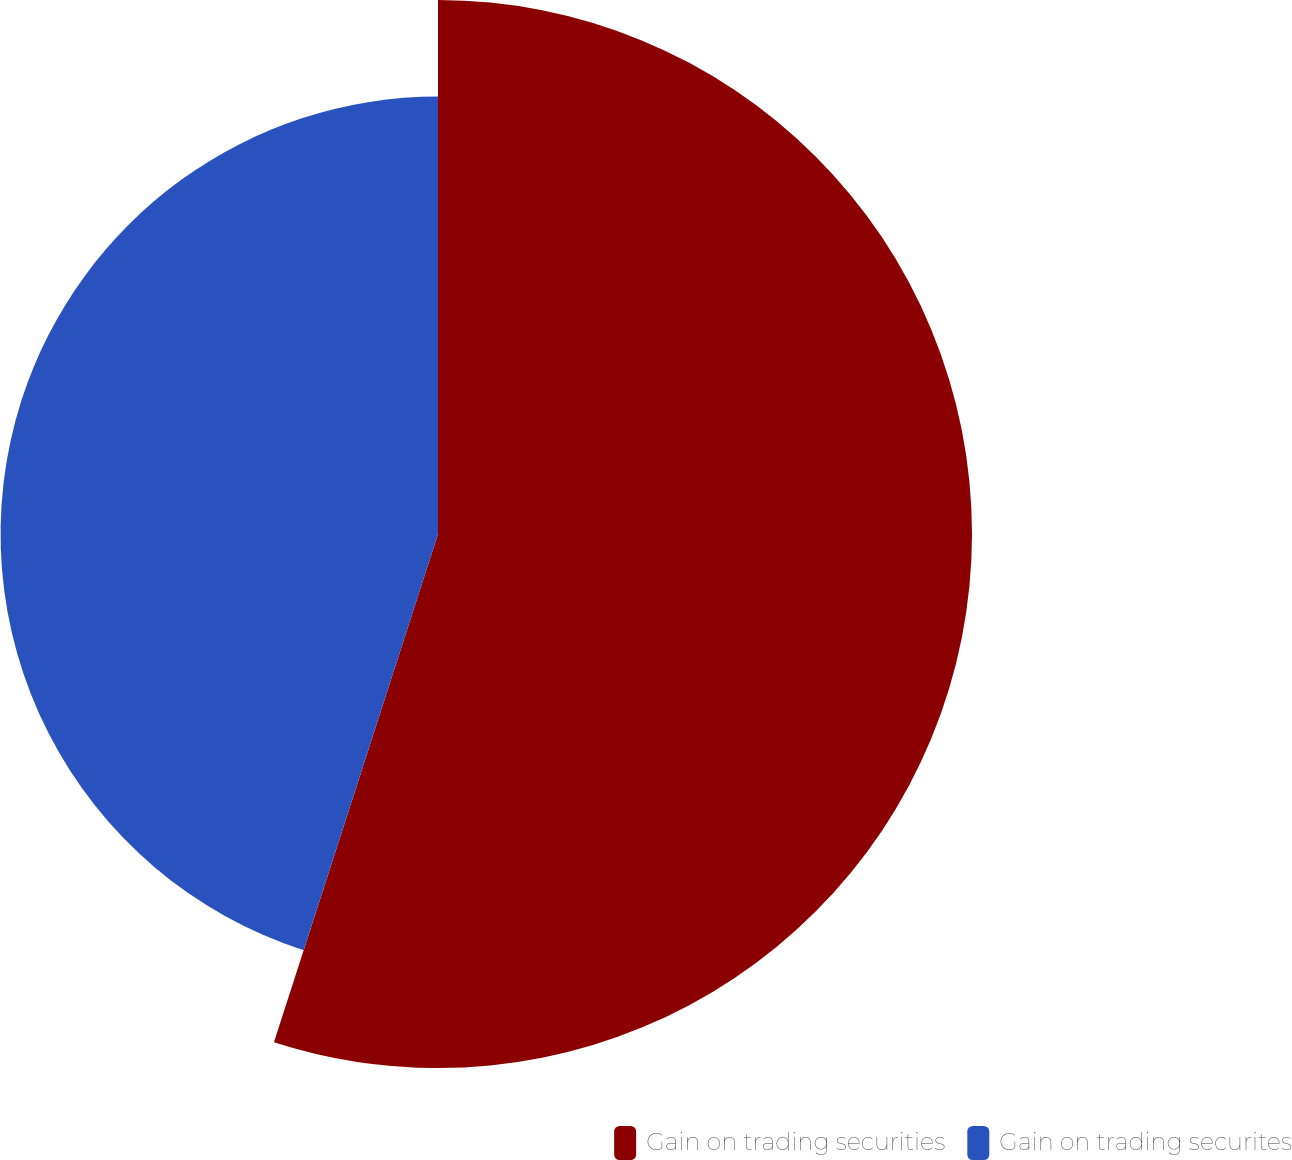Convert chart. <chart><loc_0><loc_0><loc_500><loc_500><pie_chart><fcel>Gain on trading securities<fcel>Gain on trading securites<nl><fcel>54.97%<fcel>45.03%<nl></chart> 